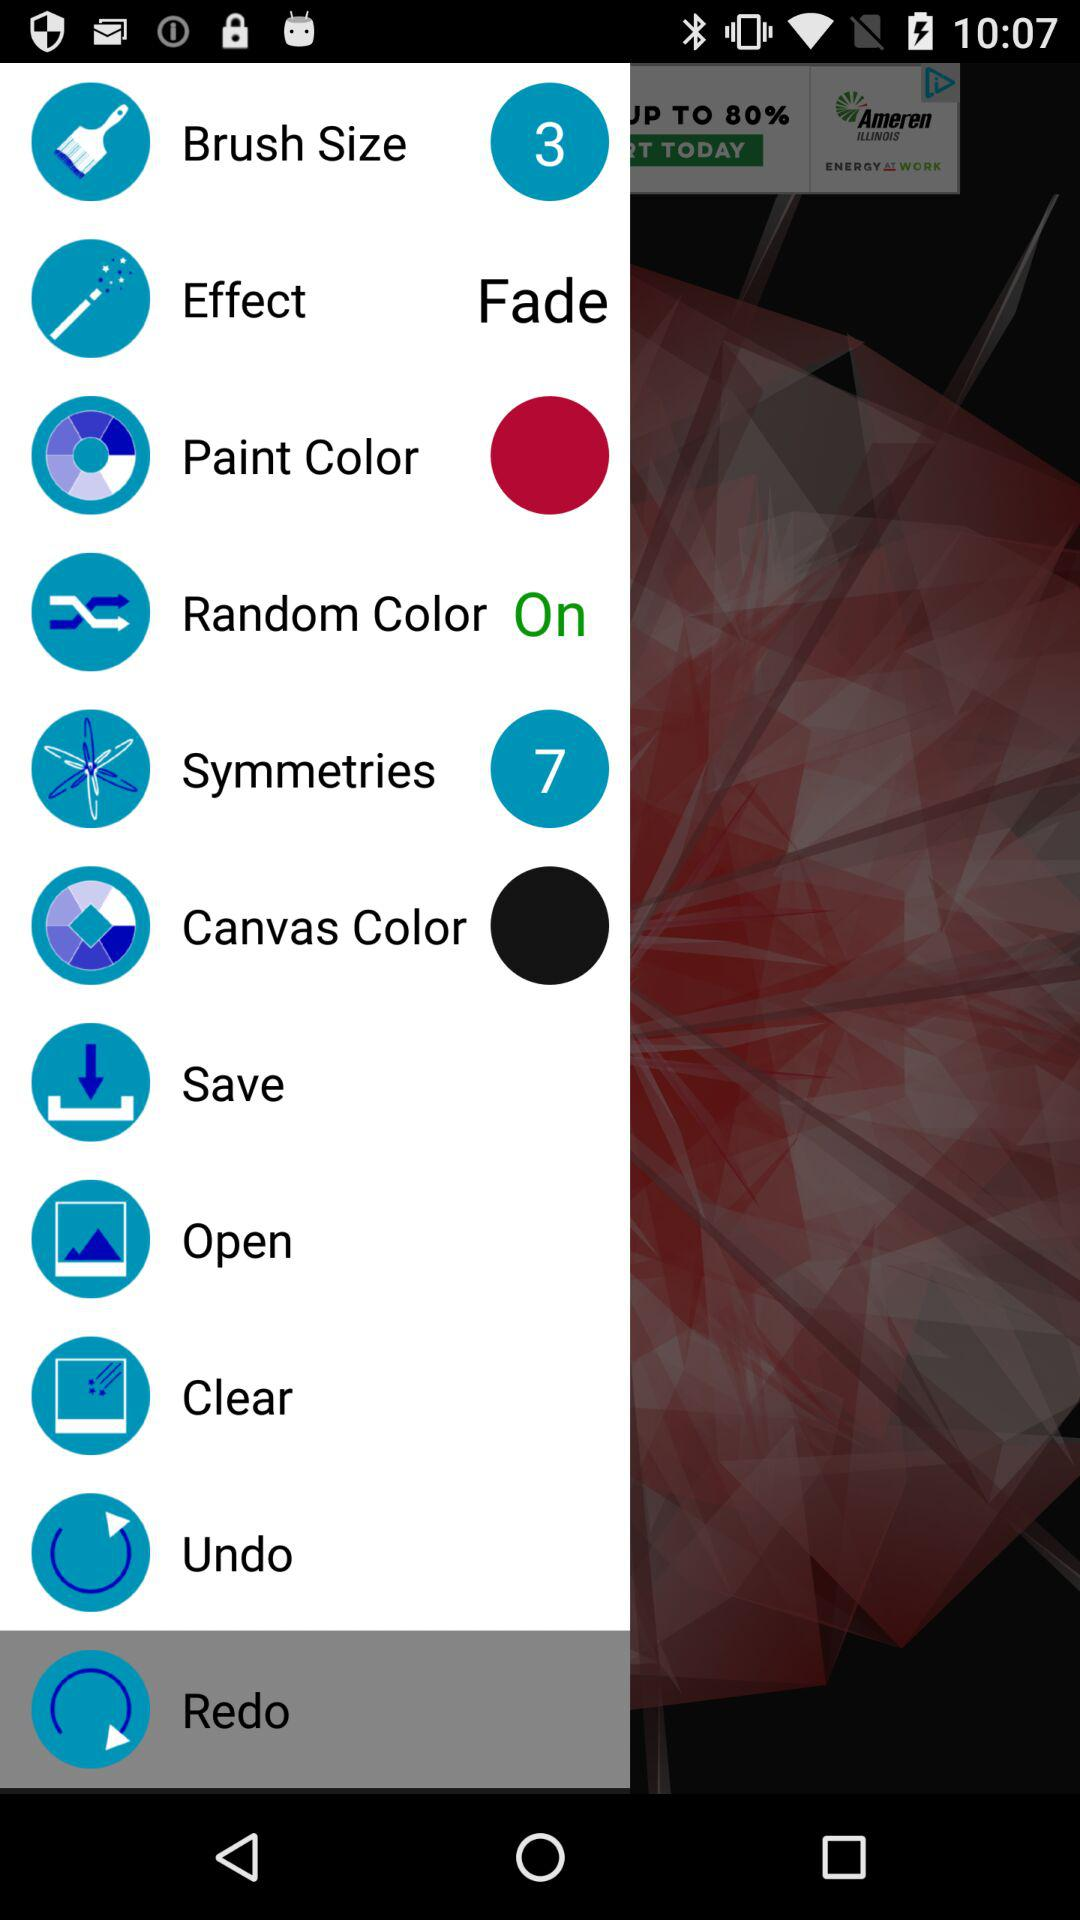Which effect is selected? The selected effect is "Fade". 